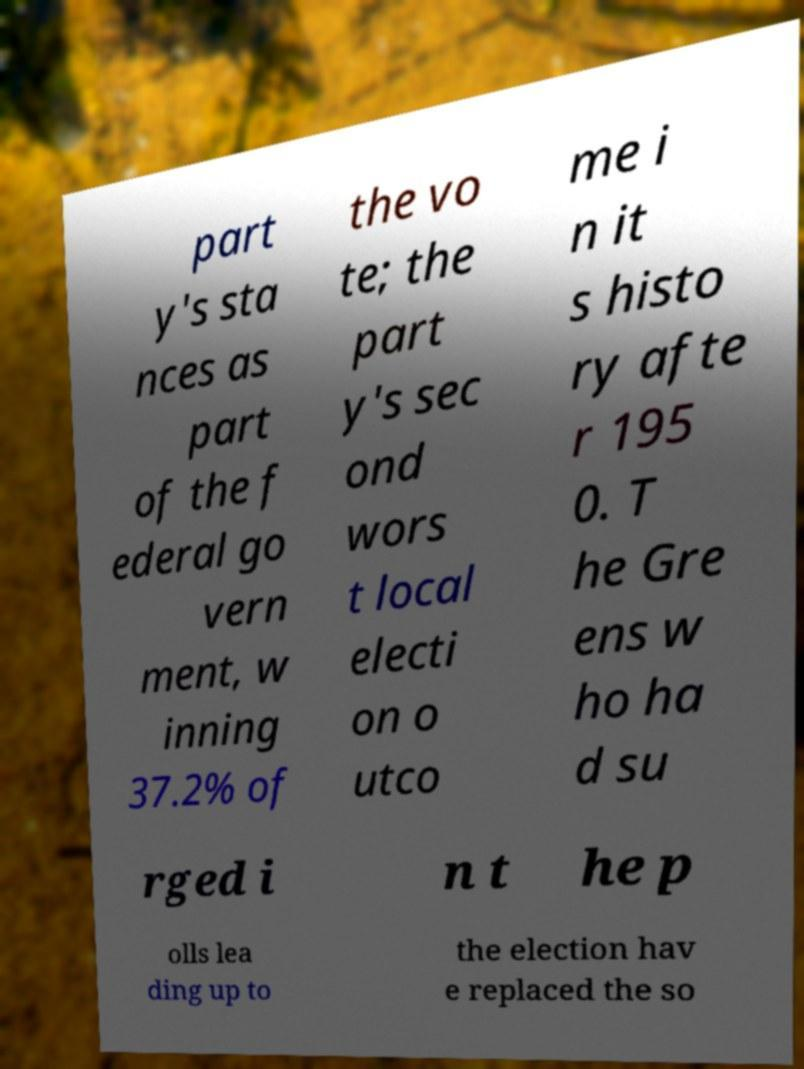Could you extract and type out the text from this image? part y's sta nces as part of the f ederal go vern ment, w inning 37.2% of the vo te; the part y's sec ond wors t local electi on o utco me i n it s histo ry afte r 195 0. T he Gre ens w ho ha d su rged i n t he p olls lea ding up to the election hav e replaced the so 